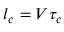Convert formula to latex. <formula><loc_0><loc_0><loc_500><loc_500>l _ { c } = V \tau _ { c }</formula> 